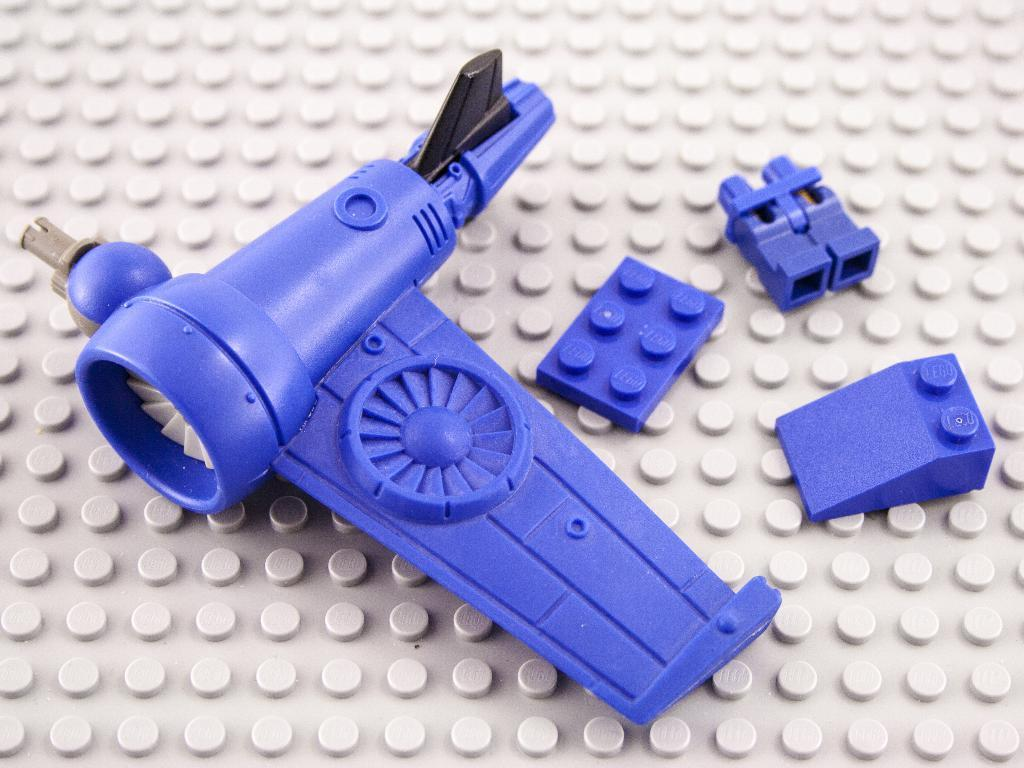What type of toys are in the image? There are Lego toys in the image. What color are the Lego toys? The Lego toys are blue in color. On what surface are the Lego toys placed? The Lego toys are kept on a white surface. How many eggs can be seen in the image? There are no eggs present in the image; it features Lego toys. Is there any milk visible in the image? There is no milk present in the image; it features Lego toys. 